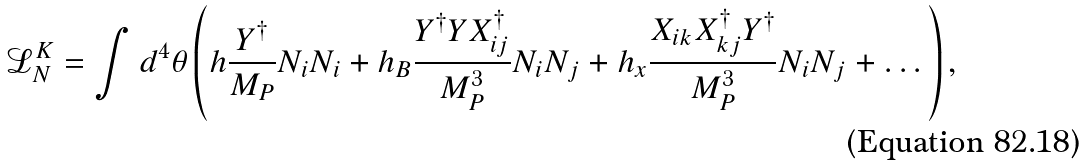Convert formula to latex. <formula><loc_0><loc_0><loc_500><loc_500>\mathcal { L } _ { N } ^ { K } = \int d ^ { 4 } \theta \left ( h \frac { Y ^ { \dagger } } { M _ { P } } N _ { i } N _ { i } + h _ { B } \frac { Y ^ { \dagger } Y X _ { i j } ^ { \dagger } } { M _ { P } ^ { 3 } } N _ { i } N _ { j } + h _ { x } \frac { X _ { i k } X _ { k j } ^ { \dagger } Y ^ { \dagger } } { M _ { P } ^ { 3 } } N _ { i } N _ { j } + \dots \right ) ,</formula> 